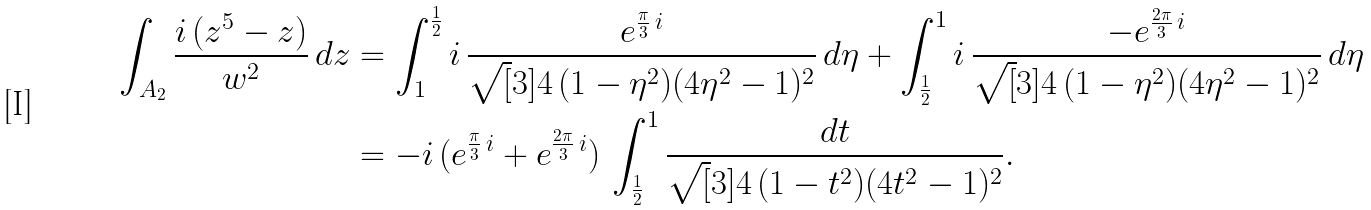<formula> <loc_0><loc_0><loc_500><loc_500>\int _ { A _ { 2 } } \frac { i \, ( z ^ { 5 } - z ) } { w ^ { 2 } } \, d z & = \int ^ { \frac { 1 } { 2 } } _ { 1 } i \, \frac { e ^ { \frac { \pi } { 3 } \, i } } { \sqrt { [ } 3 ] { 4 \, ( 1 - \eta ^ { 2 } ) ( 4 \eta ^ { 2 } - 1 ) ^ { 2 } } } \, d \eta + \int _ { \frac { 1 } { 2 } } ^ { 1 } i \, \frac { - e ^ { \frac { 2 \pi } { 3 } \, i } } { \sqrt { [ } 3 ] { 4 \, ( 1 - \eta ^ { 2 } ) ( 4 \eta ^ { 2 } - 1 ) ^ { 2 } } } \, d \eta \\ & = - i \, ( e ^ { \frac { \pi } { 3 } \, i } + e ^ { \frac { 2 \pi } { 3 } \, i } ) \, \int ^ { 1 } _ { \frac { 1 } { 2 } } \frac { d t } { \sqrt { [ } 3 ] { 4 \, ( 1 - t ^ { 2 } ) ( 4 t ^ { 2 } - 1 ) ^ { 2 } } } .</formula> 